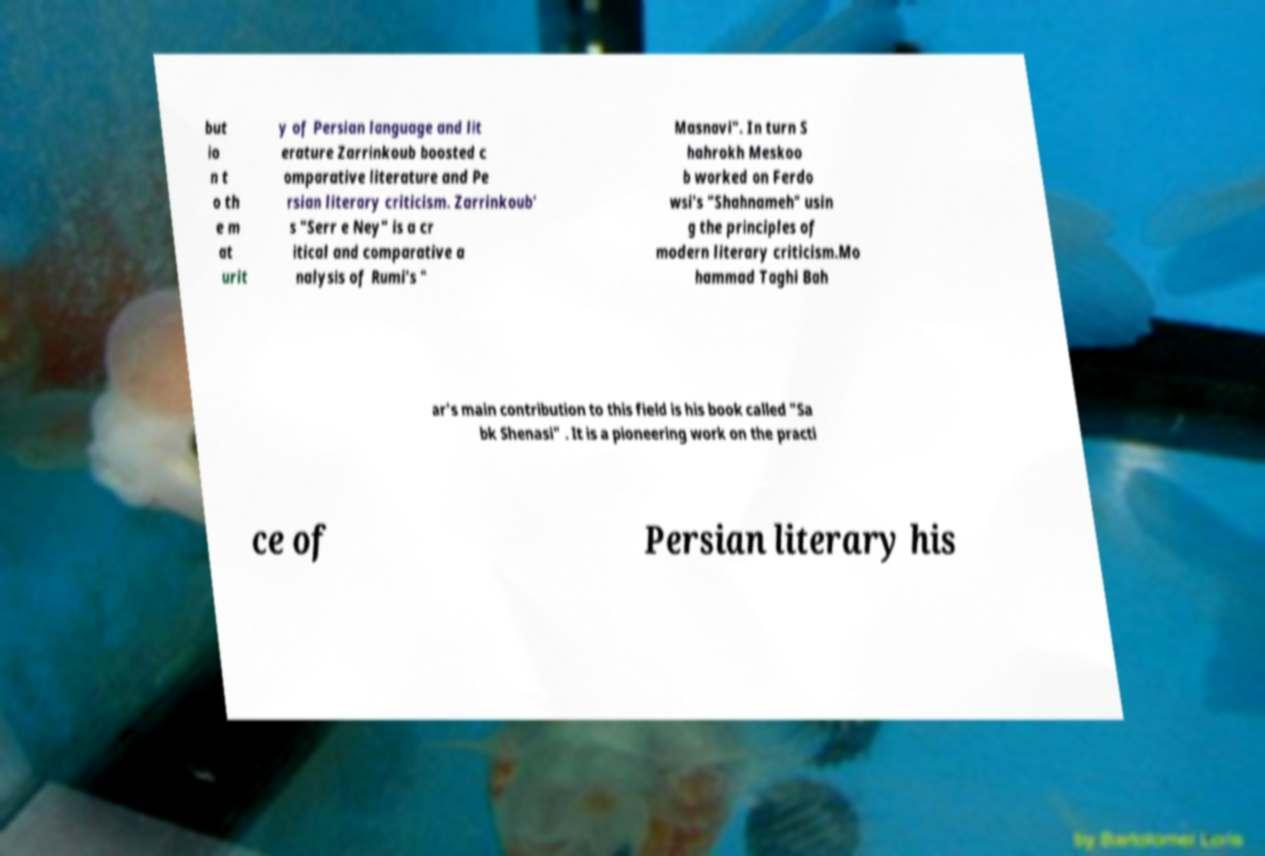There's text embedded in this image that I need extracted. Can you transcribe it verbatim? but io n t o th e m at urit y of Persian language and lit erature Zarrinkoub boosted c omparative literature and Pe rsian literary criticism. Zarrinkoub' s "Serr e Ney" is a cr itical and comparative a nalysis of Rumi's " Masnavi". In turn S hahrokh Meskoo b worked on Ferdo wsi's "Shahnameh" usin g the principles of modern literary criticism.Mo hammad Taghi Bah ar's main contribution to this field is his book called "Sa bk Shenasi" . It is a pioneering work on the practi ce of Persian literary his 